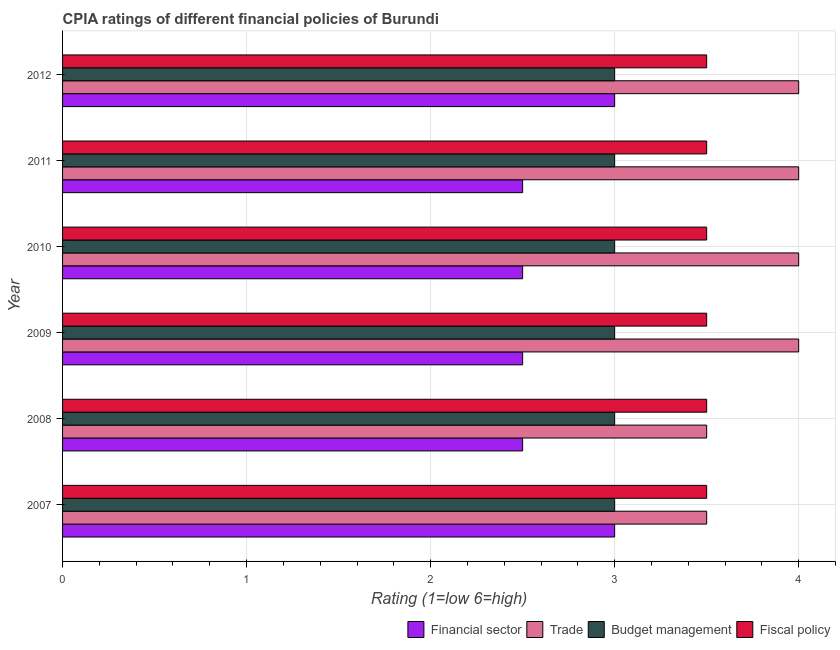How many different coloured bars are there?
Your response must be concise. 4. Are the number of bars per tick equal to the number of legend labels?
Make the answer very short. Yes. Are the number of bars on each tick of the Y-axis equal?
Ensure brevity in your answer.  Yes. How many bars are there on the 3rd tick from the bottom?
Ensure brevity in your answer.  4. What is the label of the 5th group of bars from the top?
Offer a very short reply. 2008. In how many cases, is the number of bars for a given year not equal to the number of legend labels?
Make the answer very short. 0. What is the cpia rating of budget management in 2010?
Make the answer very short. 3. In which year was the cpia rating of trade minimum?
Provide a succinct answer. 2007. What is the difference between the cpia rating of trade in 2007 and that in 2009?
Provide a succinct answer. -0.5. What is the difference between the cpia rating of financial sector in 2010 and the cpia rating of fiscal policy in 2011?
Provide a succinct answer. -1. What is the average cpia rating of budget management per year?
Ensure brevity in your answer.  3. In how many years, is the cpia rating of trade greater than 1.4 ?
Provide a short and direct response. 6. Is the cpia rating of financial sector in 2008 less than that in 2010?
Keep it short and to the point. No. Is the difference between the cpia rating of trade in 2010 and 2011 greater than the difference between the cpia rating of financial sector in 2010 and 2011?
Provide a succinct answer. No. What is the difference between the highest and the lowest cpia rating of financial sector?
Give a very brief answer. 0.5. In how many years, is the cpia rating of budget management greater than the average cpia rating of budget management taken over all years?
Your response must be concise. 0. Is it the case that in every year, the sum of the cpia rating of trade and cpia rating of budget management is greater than the sum of cpia rating of fiscal policy and cpia rating of financial sector?
Your response must be concise. Yes. What does the 3rd bar from the top in 2009 represents?
Your answer should be very brief. Trade. What does the 1st bar from the bottom in 2010 represents?
Give a very brief answer. Financial sector. Is it the case that in every year, the sum of the cpia rating of financial sector and cpia rating of trade is greater than the cpia rating of budget management?
Your answer should be very brief. Yes. How many bars are there?
Your answer should be very brief. 24. Are all the bars in the graph horizontal?
Your answer should be compact. Yes. What is the difference between two consecutive major ticks on the X-axis?
Your response must be concise. 1. Are the values on the major ticks of X-axis written in scientific E-notation?
Your response must be concise. No. Does the graph contain any zero values?
Give a very brief answer. No. Does the graph contain grids?
Offer a very short reply. Yes. How are the legend labels stacked?
Offer a terse response. Horizontal. What is the title of the graph?
Offer a very short reply. CPIA ratings of different financial policies of Burundi. Does "Secondary general education" appear as one of the legend labels in the graph?
Offer a terse response. No. What is the Rating (1=low 6=high) of Budget management in 2008?
Offer a very short reply. 3. What is the Rating (1=low 6=high) of Financial sector in 2009?
Keep it short and to the point. 2.5. What is the Rating (1=low 6=high) in Trade in 2009?
Make the answer very short. 4. What is the Rating (1=low 6=high) in Budget management in 2009?
Offer a terse response. 3. What is the Rating (1=low 6=high) of Financial sector in 2010?
Provide a short and direct response. 2.5. What is the Rating (1=low 6=high) in Budget management in 2010?
Offer a very short reply. 3. What is the Rating (1=low 6=high) in Financial sector in 2011?
Offer a very short reply. 2.5. What is the Rating (1=low 6=high) in Trade in 2011?
Provide a short and direct response. 4. What is the Rating (1=low 6=high) of Budget management in 2011?
Provide a short and direct response. 3. What is the Rating (1=low 6=high) of Fiscal policy in 2011?
Make the answer very short. 3.5. What is the Rating (1=low 6=high) in Budget management in 2012?
Your answer should be compact. 3. What is the Rating (1=low 6=high) of Fiscal policy in 2012?
Provide a short and direct response. 3.5. Across all years, what is the maximum Rating (1=low 6=high) in Trade?
Your answer should be compact. 4. Across all years, what is the minimum Rating (1=low 6=high) of Financial sector?
Provide a short and direct response. 2.5. Across all years, what is the minimum Rating (1=low 6=high) of Trade?
Offer a very short reply. 3.5. Across all years, what is the minimum Rating (1=low 6=high) in Fiscal policy?
Your answer should be compact. 3.5. What is the total Rating (1=low 6=high) of Budget management in the graph?
Give a very brief answer. 18. What is the difference between the Rating (1=low 6=high) of Financial sector in 2007 and that in 2008?
Make the answer very short. 0.5. What is the difference between the Rating (1=low 6=high) in Trade in 2007 and that in 2008?
Your answer should be compact. 0. What is the difference between the Rating (1=low 6=high) in Budget management in 2007 and that in 2008?
Make the answer very short. 0. What is the difference between the Rating (1=low 6=high) in Trade in 2007 and that in 2010?
Provide a succinct answer. -0.5. What is the difference between the Rating (1=low 6=high) in Budget management in 2007 and that in 2010?
Provide a short and direct response. 0. What is the difference between the Rating (1=low 6=high) of Financial sector in 2007 and that in 2011?
Your answer should be compact. 0.5. What is the difference between the Rating (1=low 6=high) of Budget management in 2007 and that in 2012?
Provide a short and direct response. 0. What is the difference between the Rating (1=low 6=high) in Fiscal policy in 2007 and that in 2012?
Offer a terse response. 0. What is the difference between the Rating (1=low 6=high) of Trade in 2008 and that in 2009?
Your answer should be compact. -0.5. What is the difference between the Rating (1=low 6=high) in Budget management in 2008 and that in 2009?
Keep it short and to the point. 0. What is the difference between the Rating (1=low 6=high) of Fiscal policy in 2008 and that in 2009?
Offer a terse response. 0. What is the difference between the Rating (1=low 6=high) in Financial sector in 2008 and that in 2010?
Offer a very short reply. 0. What is the difference between the Rating (1=low 6=high) in Fiscal policy in 2008 and that in 2010?
Provide a succinct answer. 0. What is the difference between the Rating (1=low 6=high) in Fiscal policy in 2008 and that in 2011?
Keep it short and to the point. 0. What is the difference between the Rating (1=low 6=high) of Financial sector in 2008 and that in 2012?
Keep it short and to the point. -0.5. What is the difference between the Rating (1=low 6=high) in Budget management in 2008 and that in 2012?
Ensure brevity in your answer.  0. What is the difference between the Rating (1=low 6=high) in Fiscal policy in 2008 and that in 2012?
Your response must be concise. 0. What is the difference between the Rating (1=low 6=high) of Financial sector in 2009 and that in 2010?
Your answer should be very brief. 0. What is the difference between the Rating (1=low 6=high) in Budget management in 2009 and that in 2010?
Ensure brevity in your answer.  0. What is the difference between the Rating (1=low 6=high) of Fiscal policy in 2009 and that in 2010?
Offer a very short reply. 0. What is the difference between the Rating (1=low 6=high) of Financial sector in 2009 and that in 2011?
Give a very brief answer. 0. What is the difference between the Rating (1=low 6=high) of Trade in 2009 and that in 2011?
Your answer should be compact. 0. What is the difference between the Rating (1=low 6=high) of Financial sector in 2009 and that in 2012?
Ensure brevity in your answer.  -0.5. What is the difference between the Rating (1=low 6=high) of Trade in 2009 and that in 2012?
Provide a succinct answer. 0. What is the difference between the Rating (1=low 6=high) in Financial sector in 2010 and that in 2011?
Your answer should be very brief. 0. What is the difference between the Rating (1=low 6=high) of Budget management in 2010 and that in 2011?
Provide a short and direct response. 0. What is the difference between the Rating (1=low 6=high) of Fiscal policy in 2010 and that in 2011?
Make the answer very short. 0. What is the difference between the Rating (1=low 6=high) of Fiscal policy in 2010 and that in 2012?
Your answer should be compact. 0. What is the difference between the Rating (1=low 6=high) in Budget management in 2011 and that in 2012?
Offer a terse response. 0. What is the difference between the Rating (1=low 6=high) in Fiscal policy in 2011 and that in 2012?
Offer a very short reply. 0. What is the difference between the Rating (1=low 6=high) of Financial sector in 2007 and the Rating (1=low 6=high) of Fiscal policy in 2008?
Provide a short and direct response. -0.5. What is the difference between the Rating (1=low 6=high) of Trade in 2007 and the Rating (1=low 6=high) of Budget management in 2008?
Keep it short and to the point. 0.5. What is the difference between the Rating (1=low 6=high) of Financial sector in 2007 and the Rating (1=low 6=high) of Trade in 2009?
Your answer should be very brief. -1. What is the difference between the Rating (1=low 6=high) in Financial sector in 2007 and the Rating (1=low 6=high) in Budget management in 2009?
Your response must be concise. 0. What is the difference between the Rating (1=low 6=high) of Financial sector in 2007 and the Rating (1=low 6=high) of Fiscal policy in 2009?
Make the answer very short. -0.5. What is the difference between the Rating (1=low 6=high) of Trade in 2007 and the Rating (1=low 6=high) of Budget management in 2009?
Make the answer very short. 0.5. What is the difference between the Rating (1=low 6=high) of Trade in 2007 and the Rating (1=low 6=high) of Fiscal policy in 2009?
Your answer should be compact. 0. What is the difference between the Rating (1=low 6=high) in Financial sector in 2007 and the Rating (1=low 6=high) in Trade in 2010?
Give a very brief answer. -1. What is the difference between the Rating (1=low 6=high) in Financial sector in 2007 and the Rating (1=low 6=high) in Budget management in 2010?
Ensure brevity in your answer.  0. What is the difference between the Rating (1=low 6=high) of Trade in 2007 and the Rating (1=low 6=high) of Budget management in 2010?
Your answer should be compact. 0.5. What is the difference between the Rating (1=low 6=high) of Trade in 2007 and the Rating (1=low 6=high) of Fiscal policy in 2010?
Make the answer very short. 0. What is the difference between the Rating (1=low 6=high) in Financial sector in 2007 and the Rating (1=low 6=high) in Trade in 2011?
Offer a terse response. -1. What is the difference between the Rating (1=low 6=high) of Financial sector in 2007 and the Rating (1=low 6=high) of Budget management in 2011?
Your answer should be compact. 0. What is the difference between the Rating (1=low 6=high) of Trade in 2007 and the Rating (1=low 6=high) of Fiscal policy in 2011?
Your response must be concise. 0. What is the difference between the Rating (1=low 6=high) of Budget management in 2007 and the Rating (1=low 6=high) of Fiscal policy in 2011?
Keep it short and to the point. -0.5. What is the difference between the Rating (1=low 6=high) in Trade in 2007 and the Rating (1=low 6=high) in Budget management in 2012?
Keep it short and to the point. 0.5. What is the difference between the Rating (1=low 6=high) of Financial sector in 2008 and the Rating (1=low 6=high) of Trade in 2009?
Your response must be concise. -1.5. What is the difference between the Rating (1=low 6=high) of Trade in 2008 and the Rating (1=low 6=high) of Fiscal policy in 2009?
Ensure brevity in your answer.  0. What is the difference between the Rating (1=low 6=high) in Budget management in 2008 and the Rating (1=low 6=high) in Fiscal policy in 2009?
Offer a very short reply. -0.5. What is the difference between the Rating (1=low 6=high) of Financial sector in 2008 and the Rating (1=low 6=high) of Trade in 2010?
Your answer should be compact. -1.5. What is the difference between the Rating (1=low 6=high) in Financial sector in 2008 and the Rating (1=low 6=high) in Budget management in 2010?
Your answer should be compact. -0.5. What is the difference between the Rating (1=low 6=high) of Trade in 2008 and the Rating (1=low 6=high) of Budget management in 2010?
Ensure brevity in your answer.  0.5. What is the difference between the Rating (1=low 6=high) in Trade in 2008 and the Rating (1=low 6=high) in Fiscal policy in 2010?
Your answer should be very brief. 0. What is the difference between the Rating (1=low 6=high) in Financial sector in 2008 and the Rating (1=low 6=high) in Trade in 2011?
Your answer should be compact. -1.5. What is the difference between the Rating (1=low 6=high) of Financial sector in 2008 and the Rating (1=low 6=high) of Budget management in 2011?
Make the answer very short. -0.5. What is the difference between the Rating (1=low 6=high) of Budget management in 2008 and the Rating (1=low 6=high) of Fiscal policy in 2011?
Your answer should be very brief. -0.5. What is the difference between the Rating (1=low 6=high) of Financial sector in 2008 and the Rating (1=low 6=high) of Trade in 2012?
Your response must be concise. -1.5. What is the difference between the Rating (1=low 6=high) of Trade in 2008 and the Rating (1=low 6=high) of Budget management in 2012?
Offer a terse response. 0.5. What is the difference between the Rating (1=low 6=high) in Trade in 2008 and the Rating (1=low 6=high) in Fiscal policy in 2012?
Make the answer very short. 0. What is the difference between the Rating (1=low 6=high) in Budget management in 2008 and the Rating (1=low 6=high) in Fiscal policy in 2012?
Your answer should be compact. -0.5. What is the difference between the Rating (1=low 6=high) in Trade in 2009 and the Rating (1=low 6=high) in Budget management in 2010?
Provide a short and direct response. 1. What is the difference between the Rating (1=low 6=high) of Financial sector in 2009 and the Rating (1=low 6=high) of Fiscal policy in 2011?
Offer a very short reply. -1. What is the difference between the Rating (1=low 6=high) in Trade in 2009 and the Rating (1=low 6=high) in Budget management in 2011?
Give a very brief answer. 1. What is the difference between the Rating (1=low 6=high) in Budget management in 2009 and the Rating (1=low 6=high) in Fiscal policy in 2011?
Offer a very short reply. -0.5. What is the difference between the Rating (1=low 6=high) of Trade in 2009 and the Rating (1=low 6=high) of Budget management in 2012?
Your response must be concise. 1. What is the difference between the Rating (1=low 6=high) in Budget management in 2009 and the Rating (1=low 6=high) in Fiscal policy in 2012?
Offer a terse response. -0.5. What is the difference between the Rating (1=low 6=high) of Financial sector in 2010 and the Rating (1=low 6=high) of Fiscal policy in 2011?
Keep it short and to the point. -1. What is the difference between the Rating (1=low 6=high) of Financial sector in 2010 and the Rating (1=low 6=high) of Fiscal policy in 2012?
Your answer should be compact. -1. What is the difference between the Rating (1=low 6=high) in Trade in 2010 and the Rating (1=low 6=high) in Budget management in 2012?
Keep it short and to the point. 1. What is the difference between the Rating (1=low 6=high) in Financial sector in 2011 and the Rating (1=low 6=high) in Trade in 2012?
Your response must be concise. -1.5. What is the difference between the Rating (1=low 6=high) of Financial sector in 2011 and the Rating (1=low 6=high) of Budget management in 2012?
Make the answer very short. -0.5. What is the difference between the Rating (1=low 6=high) of Financial sector in 2011 and the Rating (1=low 6=high) of Fiscal policy in 2012?
Your answer should be compact. -1. What is the difference between the Rating (1=low 6=high) of Trade in 2011 and the Rating (1=low 6=high) of Fiscal policy in 2012?
Ensure brevity in your answer.  0.5. What is the average Rating (1=low 6=high) of Financial sector per year?
Provide a succinct answer. 2.67. What is the average Rating (1=low 6=high) of Trade per year?
Provide a succinct answer. 3.83. In the year 2007, what is the difference between the Rating (1=low 6=high) in Financial sector and Rating (1=low 6=high) in Trade?
Your response must be concise. -0.5. In the year 2007, what is the difference between the Rating (1=low 6=high) of Financial sector and Rating (1=low 6=high) of Budget management?
Ensure brevity in your answer.  0. In the year 2007, what is the difference between the Rating (1=low 6=high) in Financial sector and Rating (1=low 6=high) in Fiscal policy?
Keep it short and to the point. -0.5. In the year 2007, what is the difference between the Rating (1=low 6=high) of Budget management and Rating (1=low 6=high) of Fiscal policy?
Make the answer very short. -0.5. In the year 2008, what is the difference between the Rating (1=low 6=high) of Trade and Rating (1=low 6=high) of Budget management?
Your answer should be compact. 0.5. In the year 2008, what is the difference between the Rating (1=low 6=high) of Trade and Rating (1=low 6=high) of Fiscal policy?
Your answer should be compact. 0. In the year 2008, what is the difference between the Rating (1=low 6=high) in Budget management and Rating (1=low 6=high) in Fiscal policy?
Make the answer very short. -0.5. In the year 2009, what is the difference between the Rating (1=low 6=high) of Financial sector and Rating (1=low 6=high) of Trade?
Keep it short and to the point. -1.5. In the year 2009, what is the difference between the Rating (1=low 6=high) of Financial sector and Rating (1=low 6=high) of Fiscal policy?
Your response must be concise. -1. In the year 2009, what is the difference between the Rating (1=low 6=high) in Trade and Rating (1=low 6=high) in Budget management?
Offer a very short reply. 1. In the year 2010, what is the difference between the Rating (1=low 6=high) of Financial sector and Rating (1=low 6=high) of Budget management?
Offer a very short reply. -0.5. In the year 2010, what is the difference between the Rating (1=low 6=high) in Financial sector and Rating (1=low 6=high) in Fiscal policy?
Make the answer very short. -1. In the year 2010, what is the difference between the Rating (1=low 6=high) in Trade and Rating (1=low 6=high) in Budget management?
Keep it short and to the point. 1. In the year 2010, what is the difference between the Rating (1=low 6=high) in Trade and Rating (1=low 6=high) in Fiscal policy?
Give a very brief answer. 0.5. In the year 2010, what is the difference between the Rating (1=low 6=high) in Budget management and Rating (1=low 6=high) in Fiscal policy?
Ensure brevity in your answer.  -0.5. In the year 2011, what is the difference between the Rating (1=low 6=high) in Financial sector and Rating (1=low 6=high) in Budget management?
Make the answer very short. -0.5. In the year 2011, what is the difference between the Rating (1=low 6=high) in Trade and Rating (1=low 6=high) in Fiscal policy?
Ensure brevity in your answer.  0.5. In the year 2011, what is the difference between the Rating (1=low 6=high) in Budget management and Rating (1=low 6=high) in Fiscal policy?
Provide a succinct answer. -0.5. In the year 2012, what is the difference between the Rating (1=low 6=high) in Financial sector and Rating (1=low 6=high) in Fiscal policy?
Provide a short and direct response. -0.5. What is the ratio of the Rating (1=low 6=high) in Trade in 2007 to that in 2008?
Provide a short and direct response. 1. What is the ratio of the Rating (1=low 6=high) in Financial sector in 2007 to that in 2009?
Give a very brief answer. 1.2. What is the ratio of the Rating (1=low 6=high) in Trade in 2007 to that in 2009?
Offer a very short reply. 0.88. What is the ratio of the Rating (1=low 6=high) in Budget management in 2007 to that in 2009?
Your response must be concise. 1. What is the ratio of the Rating (1=low 6=high) of Financial sector in 2007 to that in 2011?
Make the answer very short. 1.2. What is the ratio of the Rating (1=low 6=high) of Budget management in 2007 to that in 2011?
Provide a short and direct response. 1. What is the ratio of the Rating (1=low 6=high) of Fiscal policy in 2007 to that in 2011?
Provide a succinct answer. 1. What is the ratio of the Rating (1=low 6=high) of Financial sector in 2007 to that in 2012?
Make the answer very short. 1. What is the ratio of the Rating (1=low 6=high) in Trade in 2007 to that in 2012?
Your response must be concise. 0.88. What is the ratio of the Rating (1=low 6=high) of Budget management in 2007 to that in 2012?
Give a very brief answer. 1. What is the ratio of the Rating (1=low 6=high) in Budget management in 2008 to that in 2009?
Offer a very short reply. 1. What is the ratio of the Rating (1=low 6=high) in Fiscal policy in 2008 to that in 2009?
Make the answer very short. 1. What is the ratio of the Rating (1=low 6=high) of Budget management in 2008 to that in 2010?
Keep it short and to the point. 1. What is the ratio of the Rating (1=low 6=high) in Fiscal policy in 2008 to that in 2010?
Keep it short and to the point. 1. What is the ratio of the Rating (1=low 6=high) in Financial sector in 2008 to that in 2011?
Your answer should be very brief. 1. What is the ratio of the Rating (1=low 6=high) in Trade in 2008 to that in 2011?
Your response must be concise. 0.88. What is the ratio of the Rating (1=low 6=high) in Fiscal policy in 2008 to that in 2011?
Provide a succinct answer. 1. What is the ratio of the Rating (1=low 6=high) in Financial sector in 2008 to that in 2012?
Provide a succinct answer. 0.83. What is the ratio of the Rating (1=low 6=high) in Trade in 2008 to that in 2012?
Provide a succinct answer. 0.88. What is the ratio of the Rating (1=low 6=high) of Fiscal policy in 2008 to that in 2012?
Your answer should be compact. 1. What is the ratio of the Rating (1=low 6=high) in Trade in 2009 to that in 2010?
Your answer should be compact. 1. What is the ratio of the Rating (1=low 6=high) of Fiscal policy in 2009 to that in 2010?
Your answer should be compact. 1. What is the ratio of the Rating (1=low 6=high) of Trade in 2009 to that in 2011?
Your answer should be very brief. 1. What is the ratio of the Rating (1=low 6=high) in Budget management in 2009 to that in 2011?
Your answer should be very brief. 1. What is the ratio of the Rating (1=low 6=high) in Budget management in 2009 to that in 2012?
Ensure brevity in your answer.  1. What is the ratio of the Rating (1=low 6=high) in Budget management in 2010 to that in 2011?
Provide a succinct answer. 1. What is the ratio of the Rating (1=low 6=high) in Fiscal policy in 2010 to that in 2011?
Make the answer very short. 1. What is the ratio of the Rating (1=low 6=high) in Financial sector in 2010 to that in 2012?
Offer a terse response. 0.83. What is the ratio of the Rating (1=low 6=high) in Trade in 2010 to that in 2012?
Provide a short and direct response. 1. What is the ratio of the Rating (1=low 6=high) in Budget management in 2010 to that in 2012?
Your response must be concise. 1. What is the ratio of the Rating (1=low 6=high) in Financial sector in 2011 to that in 2012?
Offer a very short reply. 0.83. What is the ratio of the Rating (1=low 6=high) of Budget management in 2011 to that in 2012?
Keep it short and to the point. 1. What is the difference between the highest and the second highest Rating (1=low 6=high) of Trade?
Your answer should be compact. 0. What is the difference between the highest and the second highest Rating (1=low 6=high) in Budget management?
Keep it short and to the point. 0. What is the difference between the highest and the second highest Rating (1=low 6=high) of Fiscal policy?
Give a very brief answer. 0. What is the difference between the highest and the lowest Rating (1=low 6=high) in Trade?
Make the answer very short. 0.5. What is the difference between the highest and the lowest Rating (1=low 6=high) in Budget management?
Your answer should be compact. 0. What is the difference between the highest and the lowest Rating (1=low 6=high) of Fiscal policy?
Your answer should be very brief. 0. 